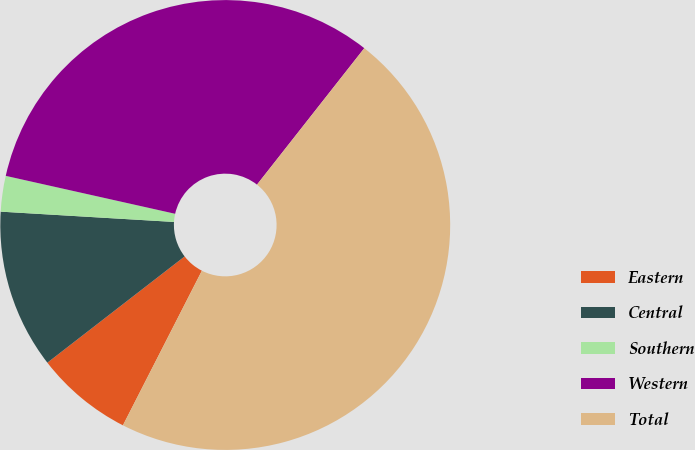Convert chart to OTSL. <chart><loc_0><loc_0><loc_500><loc_500><pie_chart><fcel>Eastern<fcel>Central<fcel>Southern<fcel>Western<fcel>Total<nl><fcel>7.0%<fcel>11.43%<fcel>2.56%<fcel>32.1%<fcel>46.91%<nl></chart> 